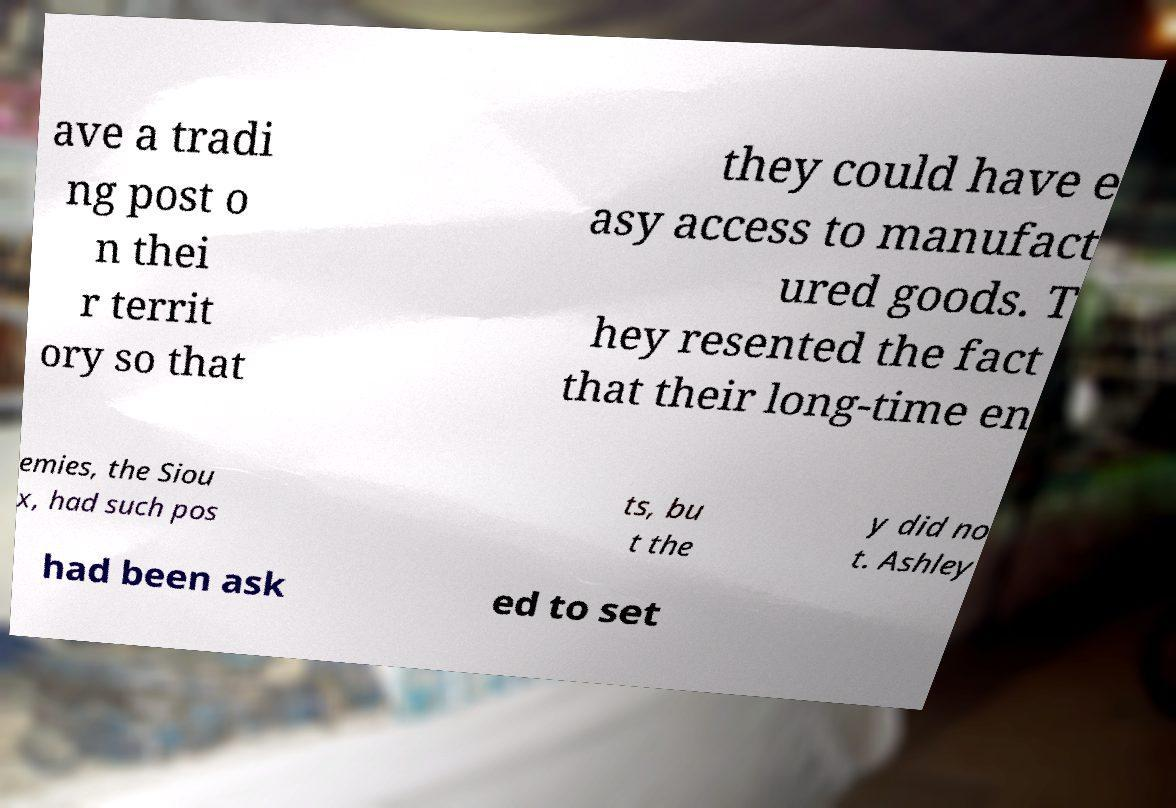For documentation purposes, I need the text within this image transcribed. Could you provide that? ave a tradi ng post o n thei r territ ory so that they could have e asy access to manufact ured goods. T hey resented the fact that their long-time en emies, the Siou x, had such pos ts, bu t the y did no t. Ashley had been ask ed to set 